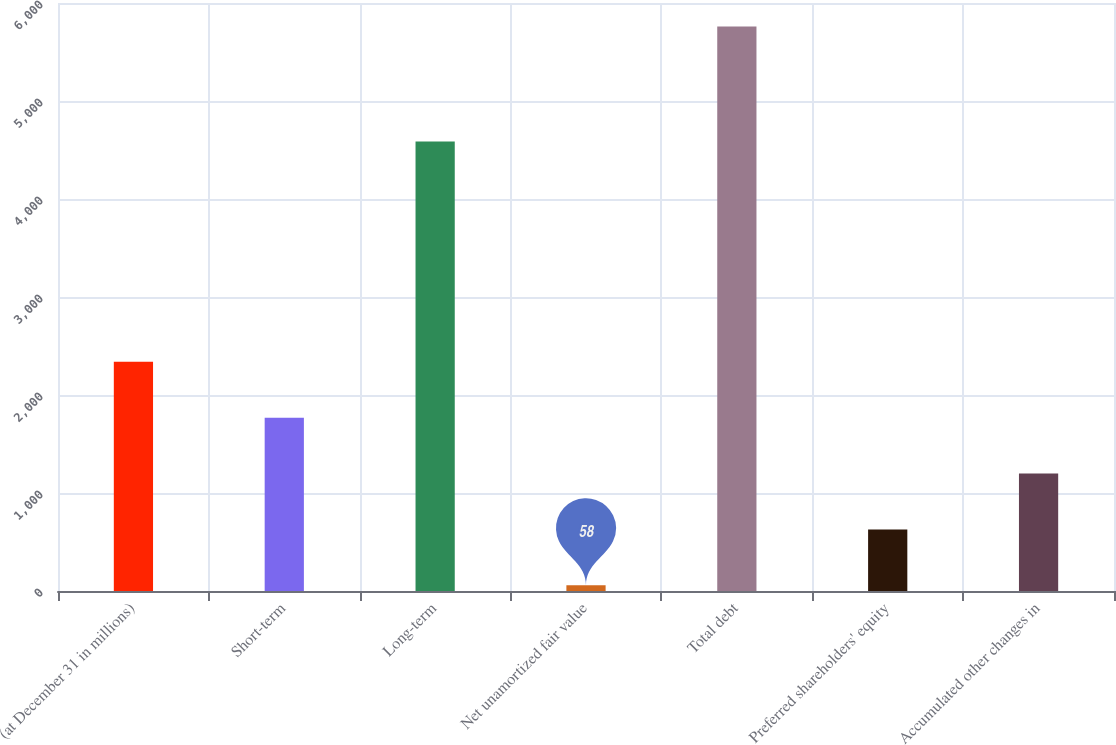<chart> <loc_0><loc_0><loc_500><loc_500><bar_chart><fcel>(at December 31 in millions)<fcel>Short-term<fcel>Long-term<fcel>Net unamortized fair value<fcel>Total debt<fcel>Preferred shareholders' equity<fcel>Accumulated other changes in<nl><fcel>2338.8<fcel>1768.6<fcel>4588<fcel>58<fcel>5760<fcel>628.2<fcel>1198.4<nl></chart> 